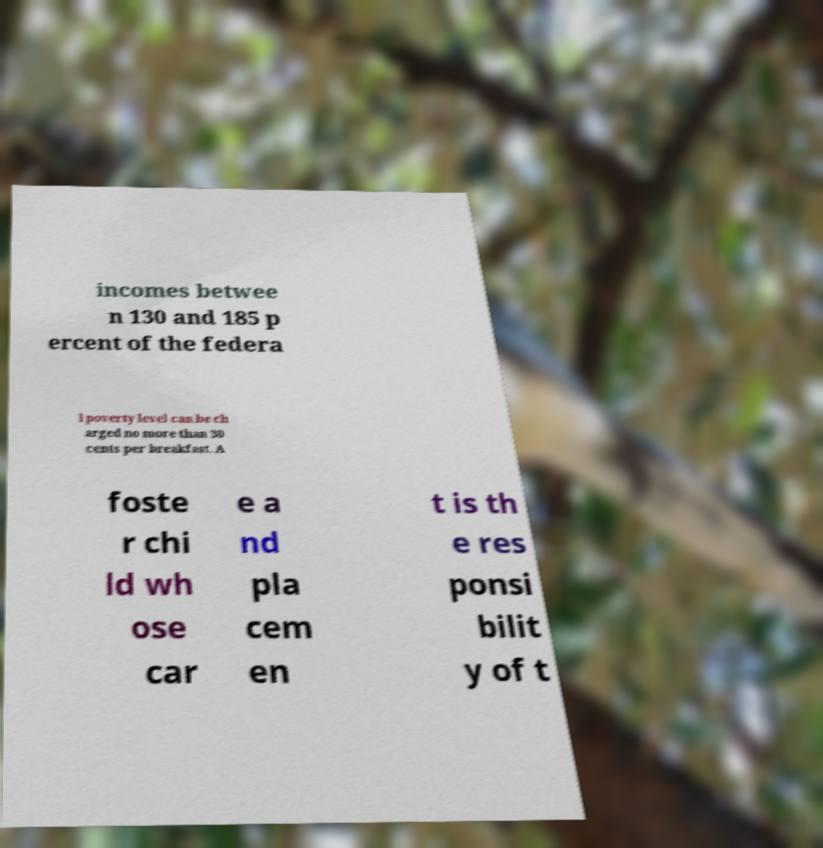What messages or text are displayed in this image? I need them in a readable, typed format. incomes betwee n 130 and 185 p ercent of the federa l poverty level can be ch arged no more than 30 cents per breakfast. A foste r chi ld wh ose car e a nd pla cem en t is th e res ponsi bilit y of t 